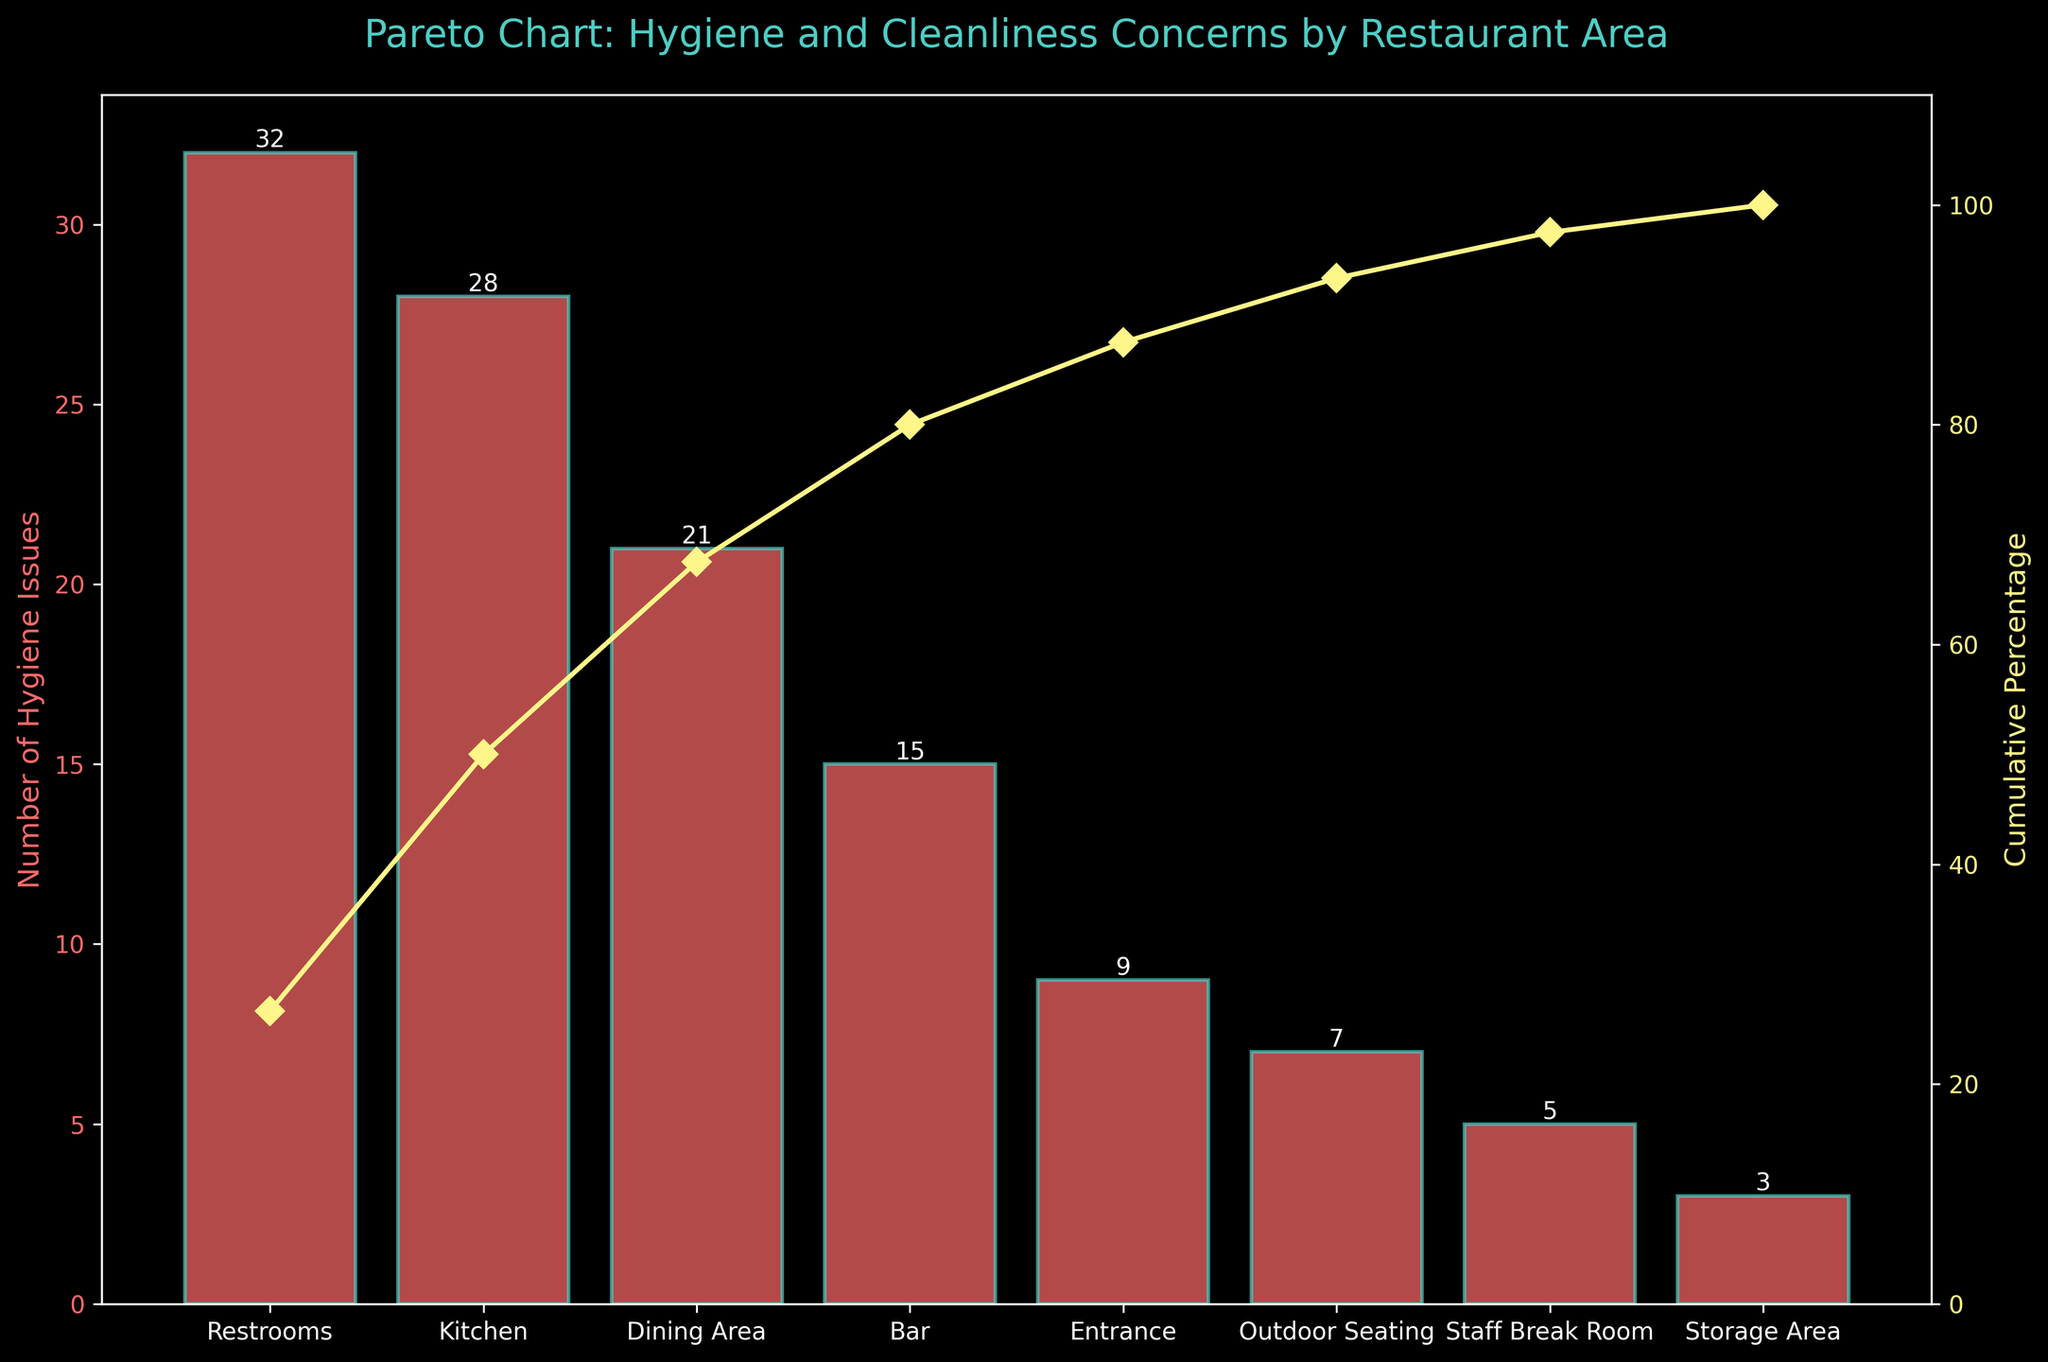What is the title of the chart? The title is displayed at the top of the chart in a larger font than the rest of the text.
Answer: Pareto Chart: Hygiene and Cleanliness Concerns by Restaurant Area Which area has the most hygiene issues? The area with the highest bar represents the area with the most hygiene issues.
Answer: Restrooms How many hygiene issues are in the Kitchen area? Look for the bar labeled "Kitchen" and read its height or the value label.
Answer: 28 What is the cumulative percentage of hygiene issues covered by the top three areas? Sum the values of the top three areas (Restrooms, Kitchen, and Dining Area). Calculate the cumulative percentage by adding their percentages from the cumulative percentage line.
Answer: 81% Which area has fewer hygiene issues, Entrance or Outdoor Seating? Compare the heights of the bars labeled "Entrance" and "Outdoor Seating".
Answer: Outdoor Seating How do hygiene issues in the Bar area compare to those in the Staff Break Room? The height of the bar for "Bar" is higher than that for "Staff Break Room", indicating more issues in the Bar.
Answer: The Bar has more issues What is the cumulative percentage after including the Bar area? Add the percentage value on the cumulative line up until the Bar area.
Answer: 86.25% How many areas have more than 20 hygiene issues? Count the number of bars with heights greater than 20.
Answer: 3 Calculate the total number of hygiene issues represented in the chart. Sum all the numerical values for Hygiene Issues.
Answer: 120 Identify which areas comprise roughly 80% of the total hygiene issues. Add the cumulative percentages until you reach or approximate 80%. The areas are Restrooms, Kitchen, and Dining Area.
Answer: Restrooms, Kitchen, Dining Area 